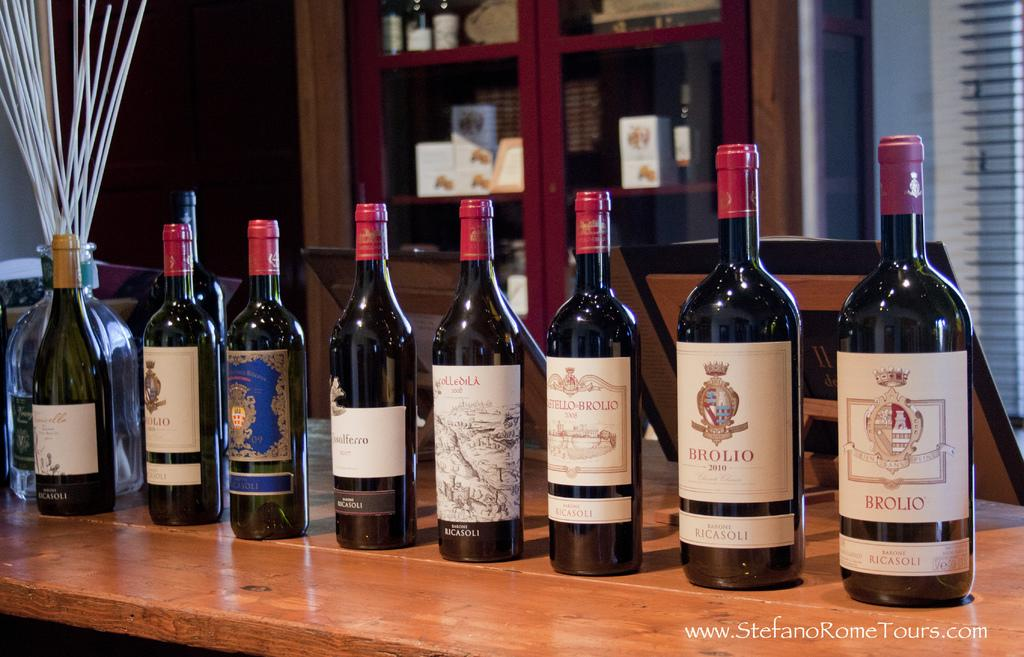<image>
Relay a brief, clear account of the picture shown. A bottle of Brolio red wine stands on display with several other bottles of wine 